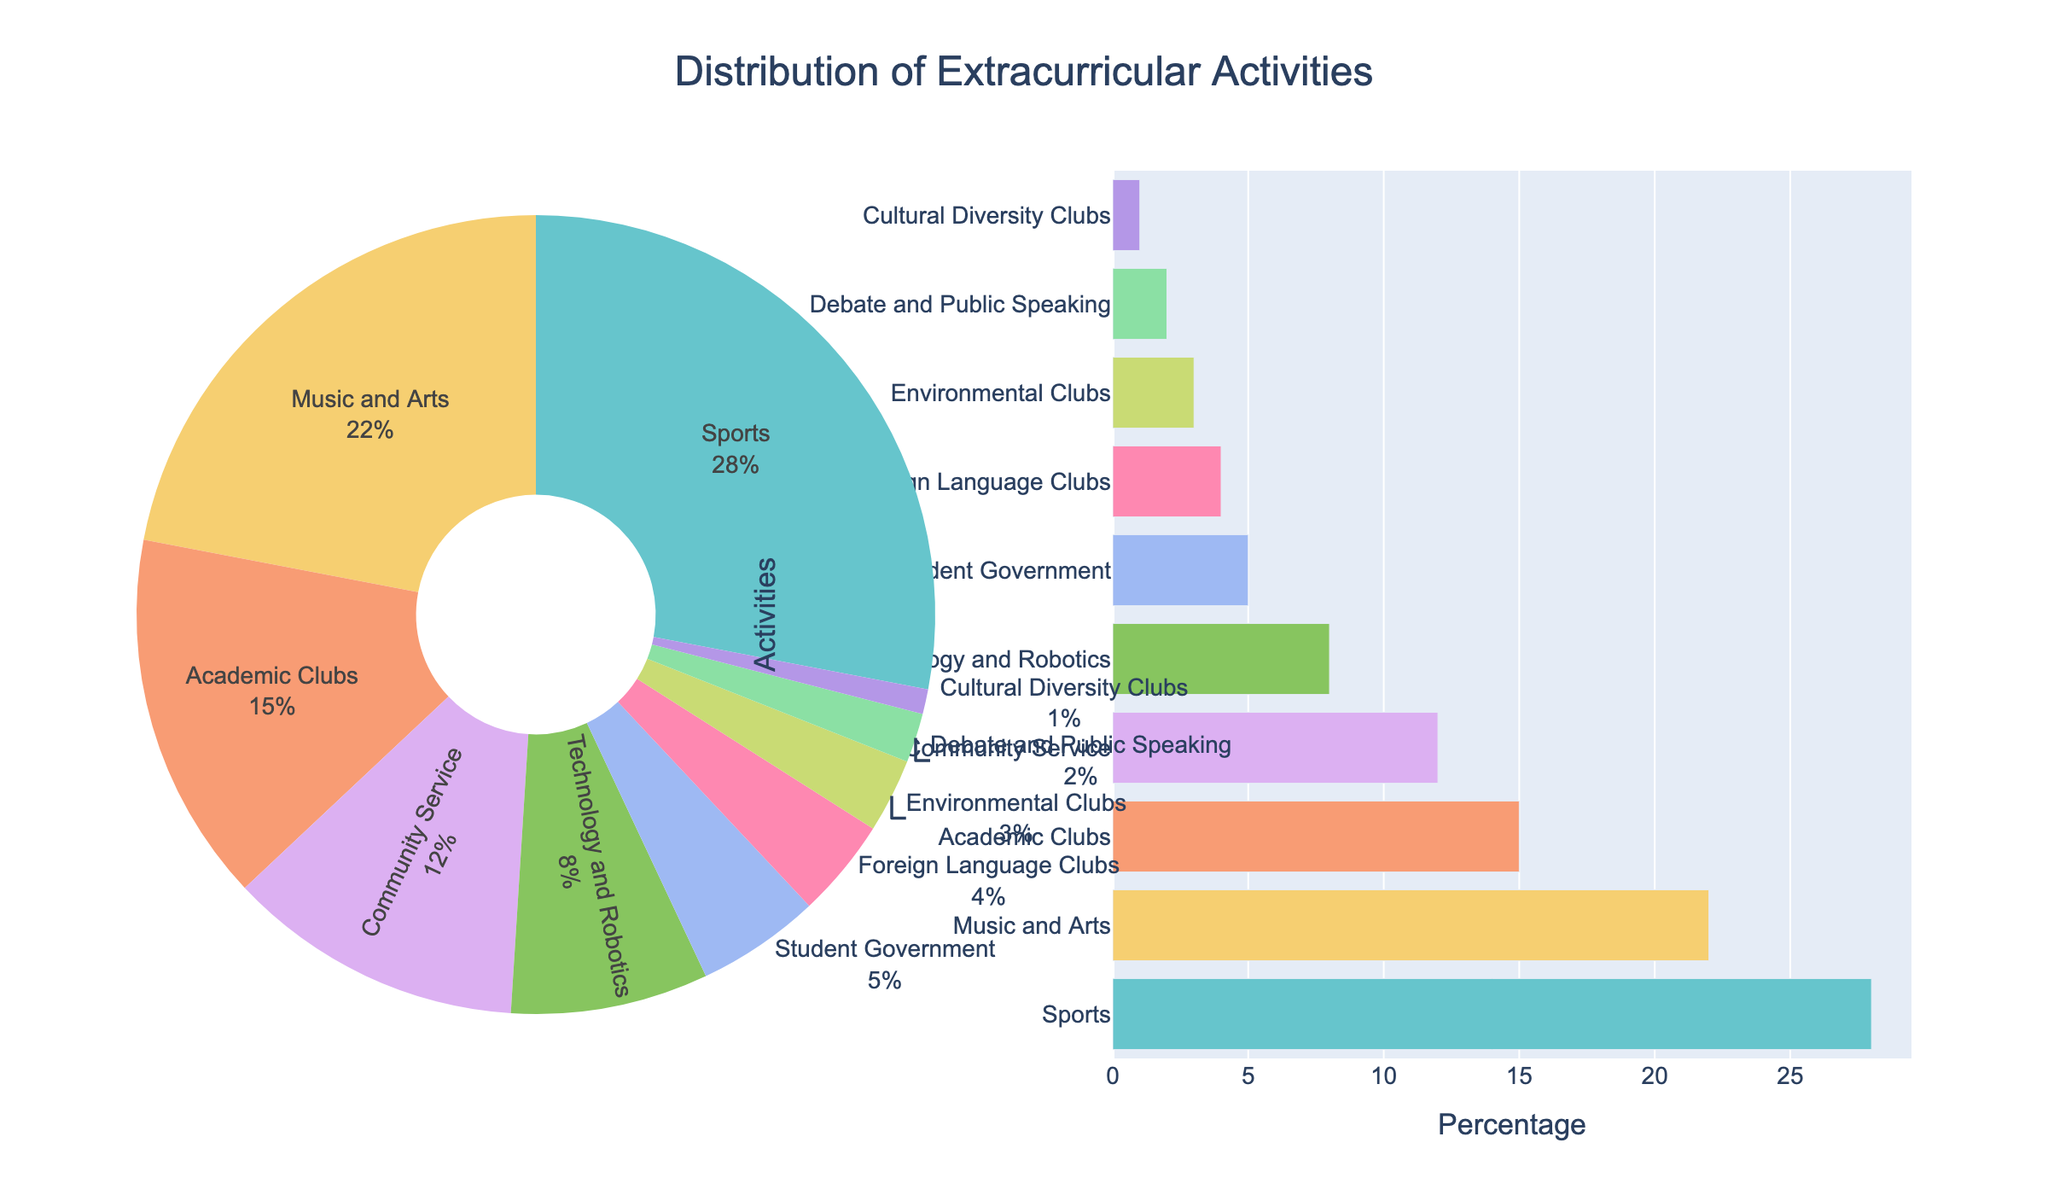What activity has the highest participation percentage? Comparing all the slices of the pie chart, the activity labeled "Sports" has the largest slice, indicating the highest percentage of participation.
Answer: Sports Which activity has a participation percentage closest to 10%? By observing the pie chart, we can see that "Community Service" has a participation percentage of 12%, which is closest to 10% among the listed activities.
Answer: Community Service Which is more popular: Music and Arts or Technology and Robotics? We look at the slices representing "Music and Arts" and "Technology and Robotics" in the pie chart. "Music and Arts" has a larger slice (22%) compared to "Technology and Robotics" (8%), making it more popular.
Answer: Music and Arts What is the combined participation percentage of Academic Clubs and Environmental Clubs? Adding the percentages for Academic Clubs (15%) and Environmental Clubs (3%), the combined participation percentage is 15% + 3% = 18%.
Answer: 18% How many activities have a participation percentage less than 5%? By examining the pie chart, we can see that there are four activities with percentages less than 5%: Student Government (5%), Foreign Language Clubs (4%), Environmental Clubs (3%), Debate and Public Speaking (2%), and Cultural Diversity Clubs (1%).
Answer: 5 Which segments of the pie chart are represented with similar colors, and what are their percentages? Observing the colors in the pie chart, "Community Service" (12%) and "Student Government" (5%) are represented with shades of orange/pink.
Answer: Community Service (12%), Student Government (5%) What is the difference in participation percentage between Sports and Academic Clubs? The participation percentage for Sports is 28% and for Academic Clubs is 15%. The difference is 28% - 15% = 13%.
Answer: 13% What is the median participation percentage among all the activities? First, we list the percentages in ascending order: 1, 2, 3, 4, 5, 8, 12, 15, 22, 28. Since there are 10 data points, the median is the average of the 5th and 6th values: (5 + 8)/2 = 6.5%.
Answer: 6.5% How many times more popular is Music and Arts compared to Debate and Public Speaking? The participation percentage for Music and Arts is 22%, and for Debate and Public Speaking is 2%. To find how many times more popular, we divide 22% by 2%, which is 11 times.
Answer: 11 times 